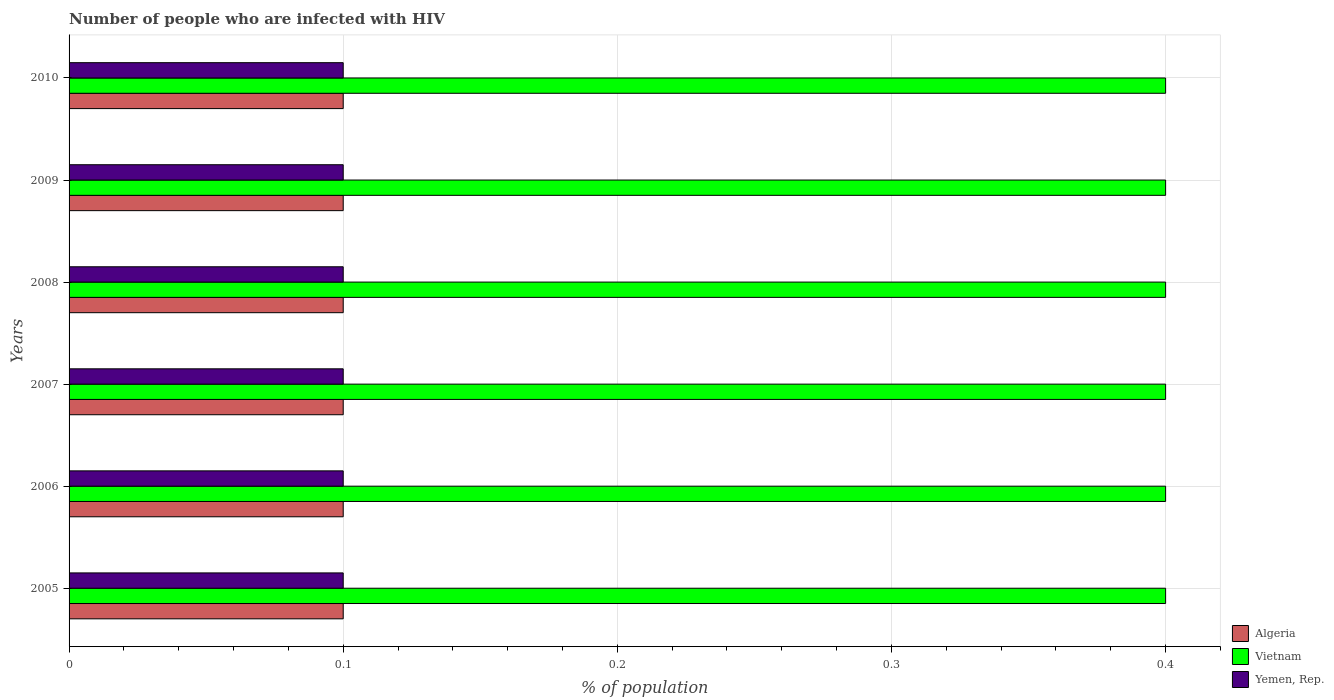How many different coloured bars are there?
Provide a short and direct response. 3. How many groups of bars are there?
Give a very brief answer. 6. Are the number of bars per tick equal to the number of legend labels?
Offer a very short reply. Yes. Are the number of bars on each tick of the Y-axis equal?
Give a very brief answer. Yes. What is the label of the 3rd group of bars from the top?
Provide a short and direct response. 2008. Across all years, what is the minimum percentage of HIV infected population in in Vietnam?
Provide a succinct answer. 0.4. In which year was the percentage of HIV infected population in in Yemen, Rep. minimum?
Make the answer very short. 2005. What is the total percentage of HIV infected population in in Yemen, Rep. in the graph?
Your answer should be compact. 0.6. What is the difference between the percentage of HIV infected population in in Vietnam in 2010 and the percentage of HIV infected population in in Yemen, Rep. in 2009?
Offer a terse response. 0.3. What is the average percentage of HIV infected population in in Yemen, Rep. per year?
Keep it short and to the point. 0.1. In the year 2005, what is the difference between the percentage of HIV infected population in in Algeria and percentage of HIV infected population in in Vietnam?
Offer a terse response. -0.3. In how many years, is the percentage of HIV infected population in in Algeria greater than 0.4 %?
Your response must be concise. 0. What is the ratio of the percentage of HIV infected population in in Vietnam in 2007 to that in 2008?
Make the answer very short. 1. Is the percentage of HIV infected population in in Yemen, Rep. in 2006 less than that in 2010?
Offer a very short reply. No. Is the difference between the percentage of HIV infected population in in Algeria in 2005 and 2010 greater than the difference between the percentage of HIV infected population in in Vietnam in 2005 and 2010?
Offer a very short reply. No. What is the difference between the highest and the lowest percentage of HIV infected population in in Vietnam?
Your response must be concise. 0. In how many years, is the percentage of HIV infected population in in Algeria greater than the average percentage of HIV infected population in in Algeria taken over all years?
Your answer should be compact. 6. What does the 1st bar from the top in 2008 represents?
Provide a succinct answer. Yemen, Rep. What does the 1st bar from the bottom in 2007 represents?
Make the answer very short. Algeria. Is it the case that in every year, the sum of the percentage of HIV infected population in in Vietnam and percentage of HIV infected population in in Yemen, Rep. is greater than the percentage of HIV infected population in in Algeria?
Offer a terse response. Yes. Are the values on the major ticks of X-axis written in scientific E-notation?
Provide a succinct answer. No. Does the graph contain grids?
Keep it short and to the point. Yes. Where does the legend appear in the graph?
Offer a very short reply. Bottom right. What is the title of the graph?
Give a very brief answer. Number of people who are infected with HIV. What is the label or title of the X-axis?
Provide a short and direct response. % of population. What is the label or title of the Y-axis?
Keep it short and to the point. Years. What is the % of population in Algeria in 2006?
Give a very brief answer. 0.1. What is the % of population in Vietnam in 2006?
Ensure brevity in your answer.  0.4. What is the % of population of Yemen, Rep. in 2006?
Offer a very short reply. 0.1. What is the % of population of Algeria in 2009?
Offer a terse response. 0.1. What is the % of population of Vietnam in 2009?
Your answer should be very brief. 0.4. What is the % of population in Yemen, Rep. in 2009?
Offer a terse response. 0.1. What is the % of population in Algeria in 2010?
Your answer should be very brief. 0.1. Across all years, what is the maximum % of population in Yemen, Rep.?
Ensure brevity in your answer.  0.1. Across all years, what is the minimum % of population of Algeria?
Your answer should be compact. 0.1. Across all years, what is the minimum % of population of Vietnam?
Offer a very short reply. 0.4. Across all years, what is the minimum % of population in Yemen, Rep.?
Offer a very short reply. 0.1. What is the total % of population in Algeria in the graph?
Provide a short and direct response. 0.6. What is the total % of population in Vietnam in the graph?
Your answer should be compact. 2.4. What is the total % of population in Yemen, Rep. in the graph?
Ensure brevity in your answer.  0.6. What is the difference between the % of population of Vietnam in 2005 and that in 2006?
Provide a succinct answer. 0. What is the difference between the % of population of Algeria in 2005 and that in 2007?
Your answer should be very brief. 0. What is the difference between the % of population in Vietnam in 2005 and that in 2008?
Keep it short and to the point. 0. What is the difference between the % of population of Yemen, Rep. in 2005 and that in 2009?
Provide a succinct answer. 0. What is the difference between the % of population of Algeria in 2005 and that in 2010?
Provide a short and direct response. 0. What is the difference between the % of population in Vietnam in 2005 and that in 2010?
Provide a succinct answer. 0. What is the difference between the % of population of Algeria in 2006 and that in 2008?
Your response must be concise. 0. What is the difference between the % of population of Algeria in 2006 and that in 2009?
Your answer should be very brief. 0. What is the difference between the % of population of Vietnam in 2006 and that in 2009?
Your response must be concise. 0. What is the difference between the % of population in Yemen, Rep. in 2006 and that in 2010?
Make the answer very short. 0. What is the difference between the % of population of Vietnam in 2007 and that in 2008?
Make the answer very short. 0. What is the difference between the % of population of Algeria in 2007 and that in 2009?
Ensure brevity in your answer.  0. What is the difference between the % of population in Yemen, Rep. in 2007 and that in 2009?
Ensure brevity in your answer.  0. What is the difference between the % of population of Algeria in 2007 and that in 2010?
Offer a terse response. 0. What is the difference between the % of population of Algeria in 2008 and that in 2009?
Your response must be concise. 0. What is the difference between the % of population of Vietnam in 2008 and that in 2009?
Keep it short and to the point. 0. What is the difference between the % of population of Yemen, Rep. in 2008 and that in 2009?
Keep it short and to the point. 0. What is the difference between the % of population in Algeria in 2008 and that in 2010?
Your response must be concise. 0. What is the difference between the % of population of Vietnam in 2008 and that in 2010?
Provide a succinct answer. 0. What is the difference between the % of population in Vietnam in 2009 and that in 2010?
Offer a very short reply. 0. What is the difference between the % of population in Algeria in 2005 and the % of population in Yemen, Rep. in 2006?
Your response must be concise. 0. What is the difference between the % of population in Algeria in 2005 and the % of population in Vietnam in 2007?
Provide a short and direct response. -0.3. What is the difference between the % of population of Algeria in 2005 and the % of population of Yemen, Rep. in 2007?
Provide a short and direct response. 0. What is the difference between the % of population of Vietnam in 2005 and the % of population of Yemen, Rep. in 2007?
Provide a succinct answer. 0.3. What is the difference between the % of population of Algeria in 2005 and the % of population of Vietnam in 2008?
Ensure brevity in your answer.  -0.3. What is the difference between the % of population of Algeria in 2005 and the % of population of Yemen, Rep. in 2008?
Provide a succinct answer. 0. What is the difference between the % of population of Algeria in 2005 and the % of population of Yemen, Rep. in 2009?
Give a very brief answer. 0. What is the difference between the % of population in Algeria in 2005 and the % of population in Yemen, Rep. in 2010?
Offer a terse response. 0. What is the difference between the % of population of Vietnam in 2005 and the % of population of Yemen, Rep. in 2010?
Keep it short and to the point. 0.3. What is the difference between the % of population of Algeria in 2006 and the % of population of Vietnam in 2007?
Provide a short and direct response. -0.3. What is the difference between the % of population in Algeria in 2006 and the % of population in Yemen, Rep. in 2010?
Make the answer very short. 0. What is the difference between the % of population in Vietnam in 2006 and the % of population in Yemen, Rep. in 2010?
Keep it short and to the point. 0.3. What is the difference between the % of population of Algeria in 2007 and the % of population of Vietnam in 2008?
Provide a short and direct response. -0.3. What is the difference between the % of population in Algeria in 2007 and the % of population in Vietnam in 2010?
Make the answer very short. -0.3. What is the difference between the % of population of Algeria in 2008 and the % of population of Yemen, Rep. in 2009?
Your answer should be very brief. 0. What is the difference between the % of population of Algeria in 2008 and the % of population of Vietnam in 2010?
Your response must be concise. -0.3. What is the difference between the % of population of Algeria in 2008 and the % of population of Yemen, Rep. in 2010?
Make the answer very short. 0. What is the difference between the % of population of Algeria in 2009 and the % of population of Yemen, Rep. in 2010?
Offer a terse response. 0. What is the difference between the % of population of Vietnam in 2009 and the % of population of Yemen, Rep. in 2010?
Provide a succinct answer. 0.3. What is the average % of population of Algeria per year?
Your response must be concise. 0.1. What is the average % of population in Vietnam per year?
Your answer should be compact. 0.4. In the year 2005, what is the difference between the % of population of Algeria and % of population of Yemen, Rep.?
Offer a very short reply. 0. In the year 2005, what is the difference between the % of population in Vietnam and % of population in Yemen, Rep.?
Provide a short and direct response. 0.3. In the year 2006, what is the difference between the % of population in Algeria and % of population in Yemen, Rep.?
Your answer should be very brief. 0. In the year 2006, what is the difference between the % of population in Vietnam and % of population in Yemen, Rep.?
Provide a short and direct response. 0.3. In the year 2007, what is the difference between the % of population of Algeria and % of population of Yemen, Rep.?
Your answer should be compact. 0. In the year 2008, what is the difference between the % of population in Algeria and % of population in Vietnam?
Your answer should be compact. -0.3. In the year 2008, what is the difference between the % of population in Vietnam and % of population in Yemen, Rep.?
Offer a terse response. 0.3. In the year 2009, what is the difference between the % of population of Algeria and % of population of Vietnam?
Provide a short and direct response. -0.3. In the year 2009, what is the difference between the % of population in Algeria and % of population in Yemen, Rep.?
Keep it short and to the point. 0. In the year 2009, what is the difference between the % of population of Vietnam and % of population of Yemen, Rep.?
Keep it short and to the point. 0.3. What is the ratio of the % of population of Algeria in 2005 to that in 2007?
Your answer should be compact. 1. What is the ratio of the % of population in Vietnam in 2005 to that in 2008?
Keep it short and to the point. 1. What is the ratio of the % of population of Algeria in 2006 to that in 2007?
Offer a very short reply. 1. What is the ratio of the % of population in Vietnam in 2006 to that in 2007?
Provide a succinct answer. 1. What is the ratio of the % of population of Yemen, Rep. in 2006 to that in 2007?
Your answer should be compact. 1. What is the ratio of the % of population of Algeria in 2006 to that in 2008?
Ensure brevity in your answer.  1. What is the ratio of the % of population of Vietnam in 2006 to that in 2008?
Offer a terse response. 1. What is the ratio of the % of population in Algeria in 2006 to that in 2009?
Your answer should be compact. 1. What is the ratio of the % of population in Yemen, Rep. in 2007 to that in 2008?
Keep it short and to the point. 1. What is the ratio of the % of population of Yemen, Rep. in 2007 to that in 2010?
Offer a very short reply. 1. What is the ratio of the % of population in Algeria in 2008 to that in 2009?
Your answer should be compact. 1. What is the ratio of the % of population in Yemen, Rep. in 2008 to that in 2010?
Offer a very short reply. 1. What is the ratio of the % of population of Algeria in 2009 to that in 2010?
Make the answer very short. 1. What is the ratio of the % of population in Vietnam in 2009 to that in 2010?
Provide a succinct answer. 1. What is the ratio of the % of population in Yemen, Rep. in 2009 to that in 2010?
Offer a very short reply. 1. What is the difference between the highest and the second highest % of population of Algeria?
Provide a succinct answer. 0. What is the difference between the highest and the lowest % of population in Vietnam?
Provide a succinct answer. 0. What is the difference between the highest and the lowest % of population in Yemen, Rep.?
Give a very brief answer. 0. 